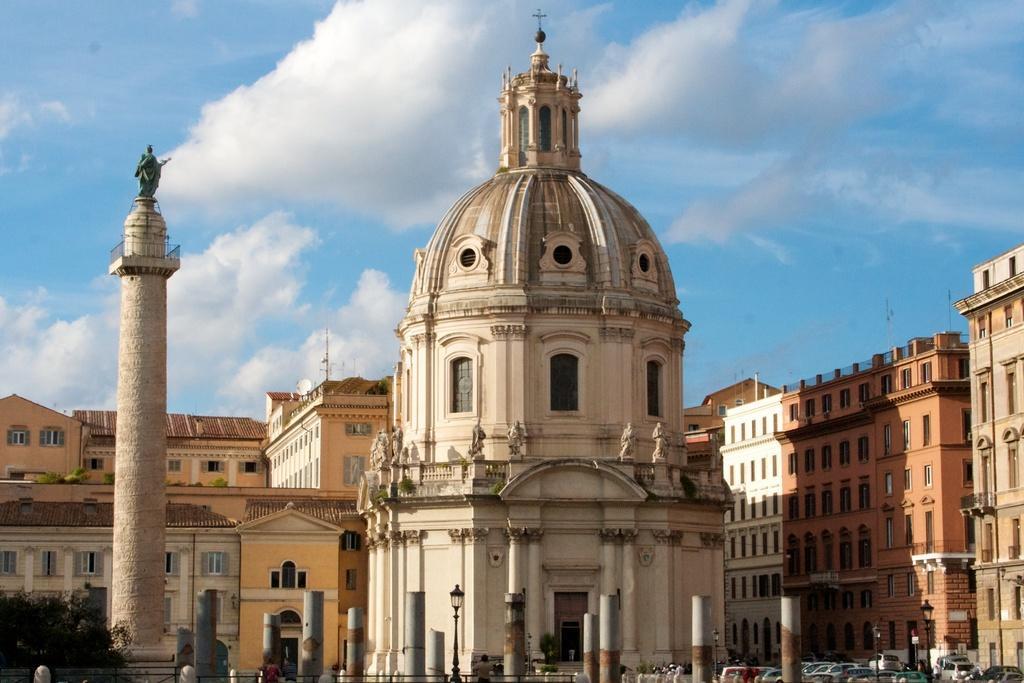Please provide a concise description of this image. Here we can see buildings, sculptures, trees, poles, persons, and vehicles. In the background there is sky with clouds. 